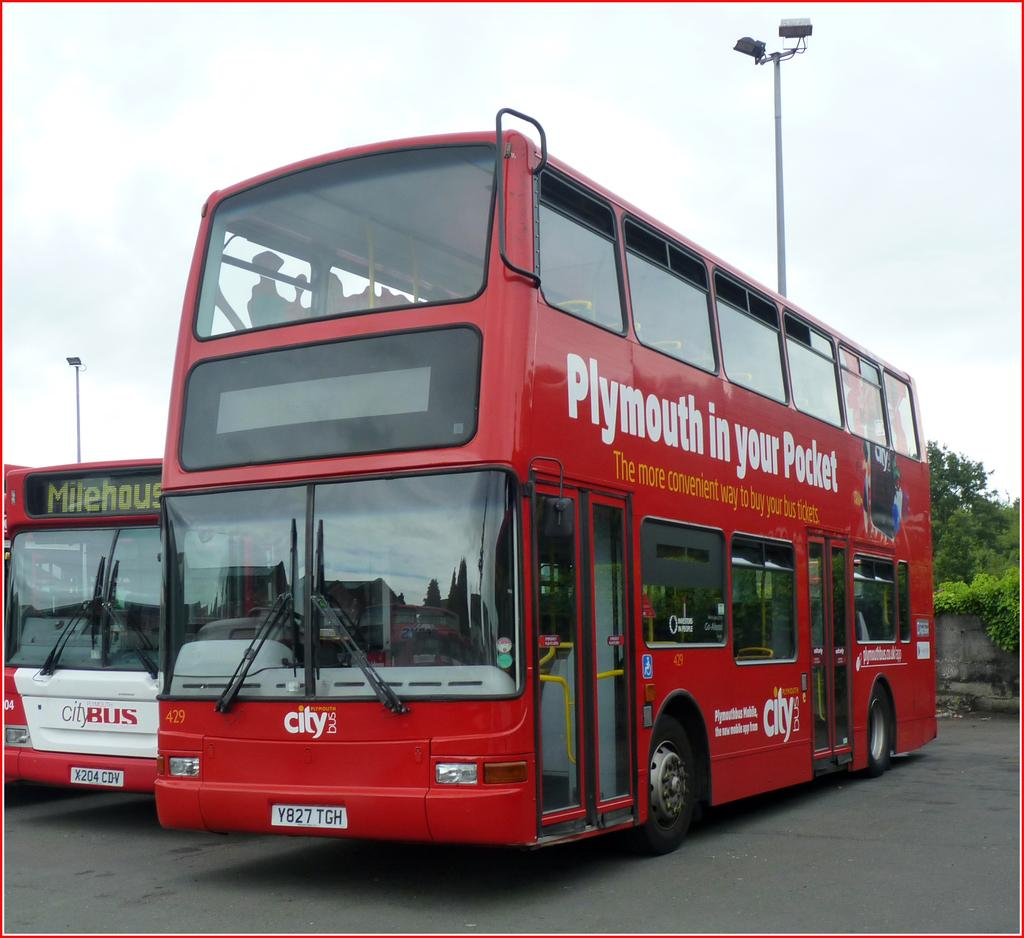<image>
Offer a succinct explanation of the picture presented. A red city bus with Plymouth in your pocket painted on its side. 